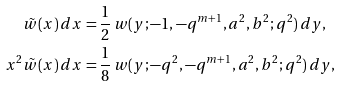Convert formula to latex. <formula><loc_0><loc_0><loc_500><loc_500>\tilde { w } ( x ) \, d x & = \frac { 1 } { 2 } \, w ( y ; - 1 , - q ^ { m + 1 } , a ^ { 2 } , b ^ { 2 } ; q ^ { 2 } ) \, d y , \\ x ^ { 2 } \tilde { w } ( x ) \, d x & = \frac { 1 } { 8 } \, w ( y ; - q ^ { 2 } , - q ^ { m + 1 } , a ^ { 2 } , b ^ { 2 } ; q ^ { 2 } ) \, d y ,</formula> 